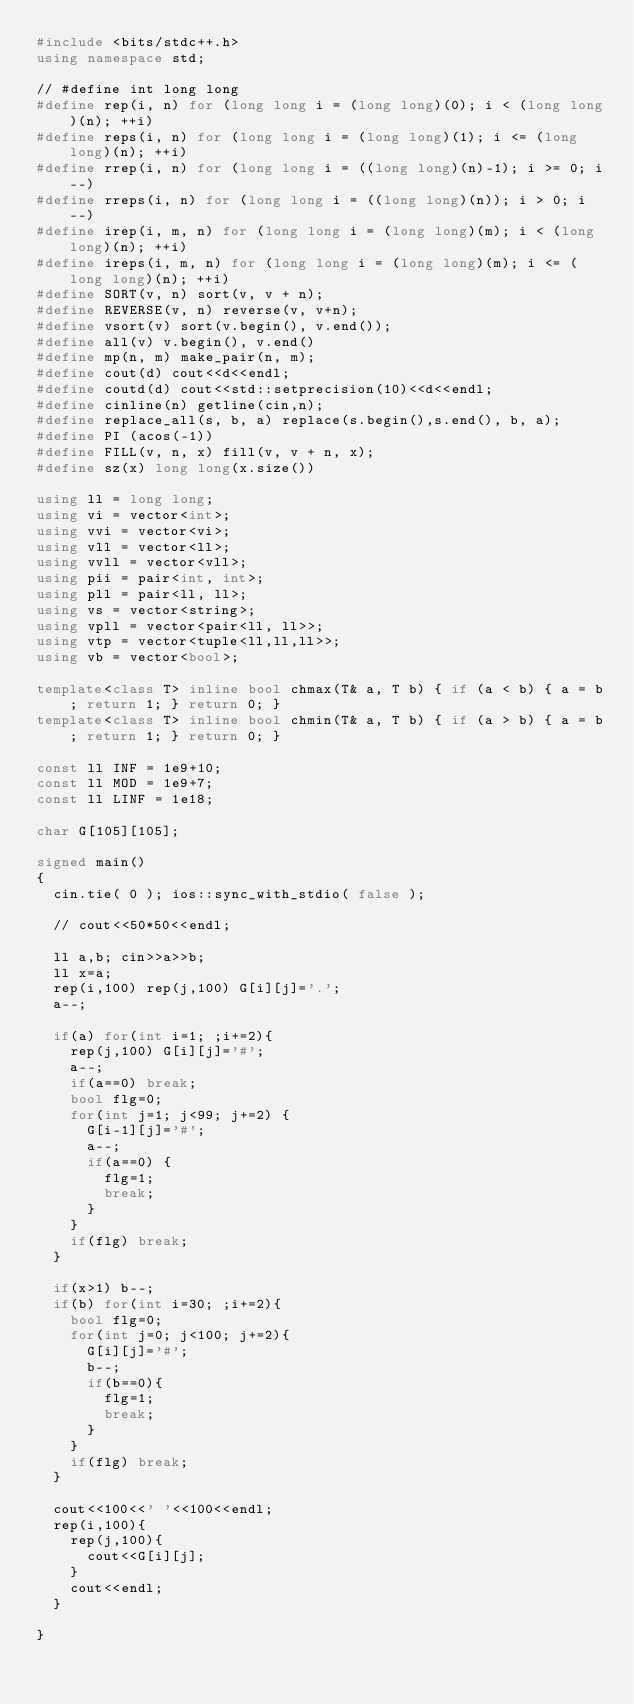<code> <loc_0><loc_0><loc_500><loc_500><_C++_>#include <bits/stdc++.h>
using namespace std;

// #define int long long
#define rep(i, n) for (long long i = (long long)(0); i < (long long)(n); ++i)
#define reps(i, n) for (long long i = (long long)(1); i <= (long long)(n); ++i)
#define rrep(i, n) for (long long i = ((long long)(n)-1); i >= 0; i--)
#define rreps(i, n) for (long long i = ((long long)(n)); i > 0; i--)
#define irep(i, m, n) for (long long i = (long long)(m); i < (long long)(n); ++i)
#define ireps(i, m, n) for (long long i = (long long)(m); i <= (long long)(n); ++i)
#define SORT(v, n) sort(v, v + n);
#define REVERSE(v, n) reverse(v, v+n);
#define vsort(v) sort(v.begin(), v.end());
#define all(v) v.begin(), v.end()
#define mp(n, m) make_pair(n, m);
#define cout(d) cout<<d<<endl;
#define coutd(d) cout<<std::setprecision(10)<<d<<endl;
#define cinline(n) getline(cin,n);
#define replace_all(s, b, a) replace(s.begin(),s.end(), b, a);
#define PI (acos(-1))
#define FILL(v, n, x) fill(v, v + n, x);
#define sz(x) long long(x.size())

using ll = long long;
using vi = vector<int>;
using vvi = vector<vi>;
using vll = vector<ll>;
using vvll = vector<vll>;
using pii = pair<int, int>;
using pll = pair<ll, ll>;
using vs = vector<string>;
using vpll = vector<pair<ll, ll>>;
using vtp = vector<tuple<ll,ll,ll>>;
using vb = vector<bool>;

template<class T> inline bool chmax(T& a, T b) { if (a < b) { a = b; return 1; } return 0; }
template<class T> inline bool chmin(T& a, T b) { if (a > b) { a = b; return 1; } return 0; }

const ll INF = 1e9+10;
const ll MOD = 1e9+7;
const ll LINF = 1e18;

char G[105][105];

signed main()
{
  cin.tie( 0 ); ios::sync_with_stdio( false );
  
  // cout<<50*50<<endl;
  
  ll a,b; cin>>a>>b;
  ll x=a;
  rep(i,100) rep(j,100) G[i][j]='.';
  a--;
  
  if(a) for(int i=1; ;i+=2){
    rep(j,100) G[i][j]='#';
    a--;
    if(a==0) break;
    bool flg=0;
    for(int j=1; j<99; j+=2) {
      G[i-1][j]='#';
      a--;
      if(a==0) {
        flg=1;
        break;
      }
    }
    if(flg) break;
  }
  
  if(x>1) b--;
  if(b) for(int i=30; ;i+=2){
    bool flg=0;
    for(int j=0; j<100; j+=2){
      G[i][j]='#';
      b--;
      if(b==0){
        flg=1;
        break;
      }
    }
    if(flg) break;
  }
  
  cout<<100<<' '<<100<<endl;
  rep(i,100){
    rep(j,100){
      cout<<G[i][j];
    }
    cout<<endl;
  }
  
}</code> 